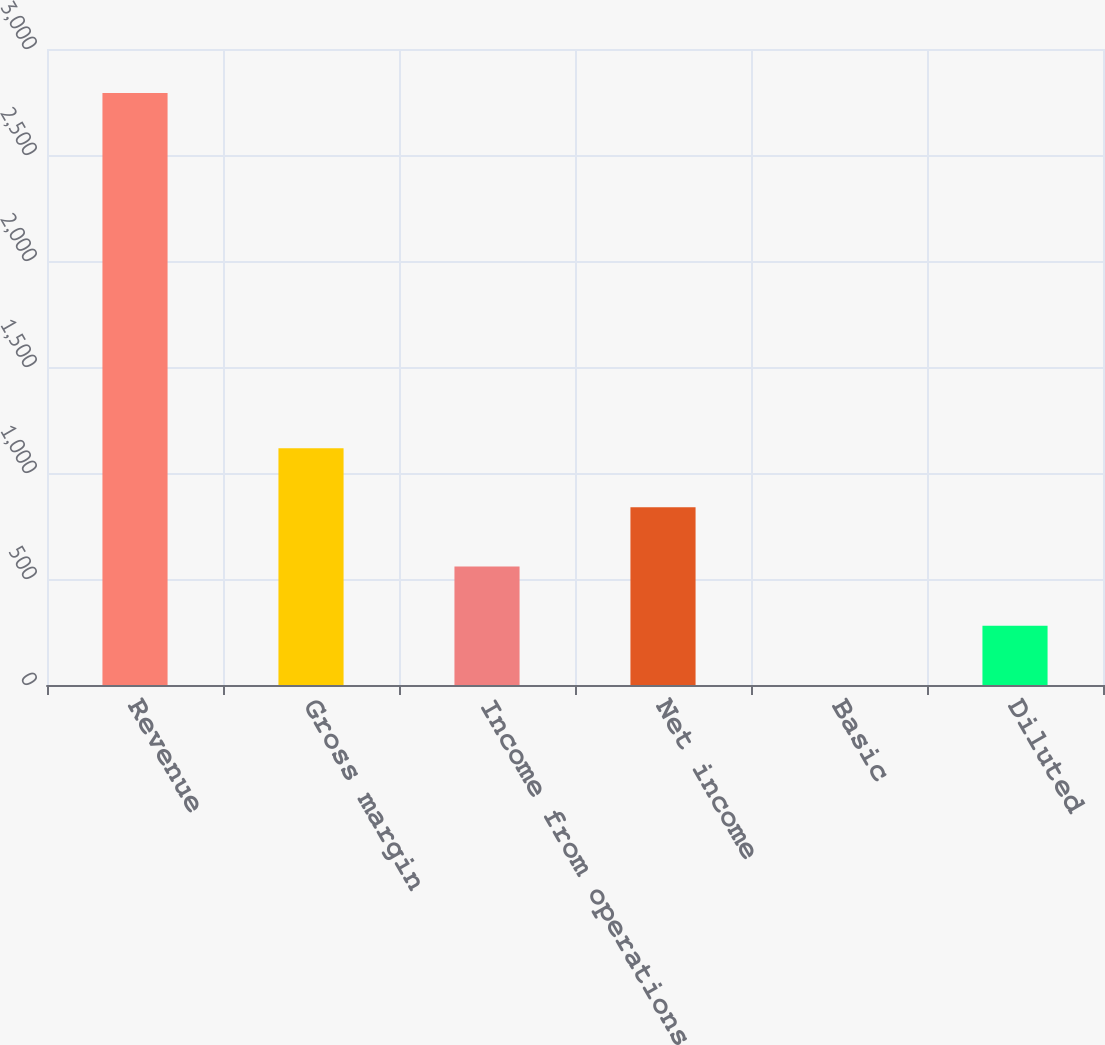Convert chart to OTSL. <chart><loc_0><loc_0><loc_500><loc_500><bar_chart><fcel>Revenue<fcel>Gross margin<fcel>Income from operations<fcel>Net income<fcel>Basic<fcel>Diluted<nl><fcel>2793<fcel>1117.23<fcel>558.63<fcel>837.93<fcel>0.03<fcel>279.33<nl></chart> 